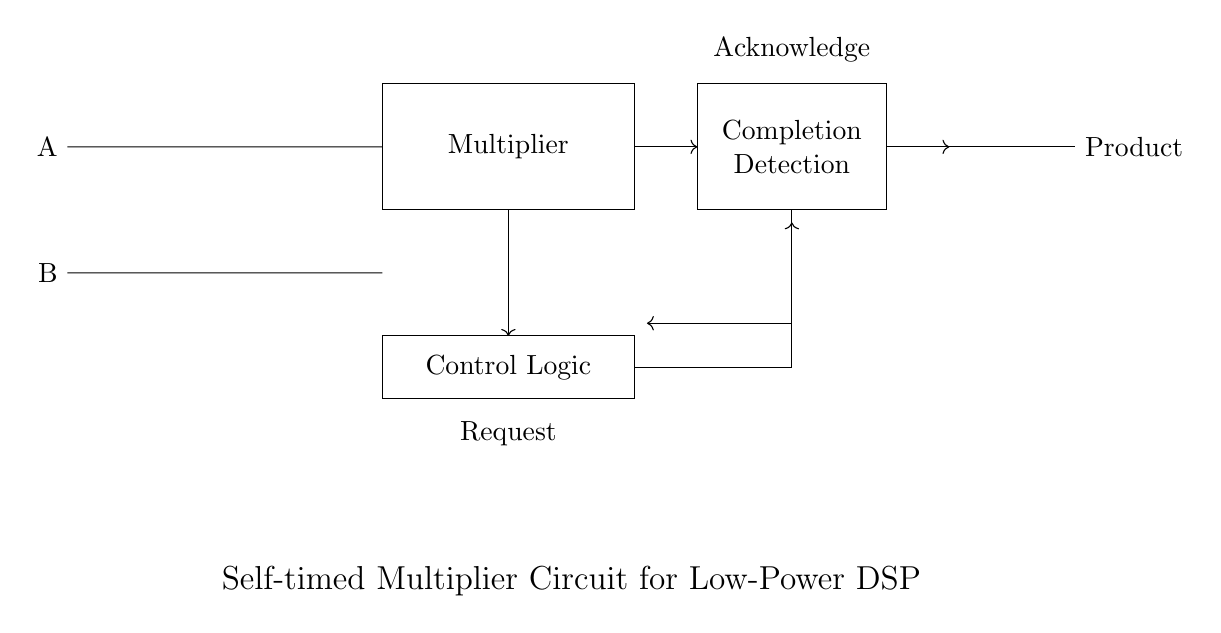What are the two input signals for the multiplier? The two input signals are labeled A and B, which are connected to the input registers on the left side of the circuit diagram.
Answer: A and B What is the purpose of the rectangle labeled "Multiplier"? The "Multiplier" block represents the core functionality of the circuit, where the actual multiplication of inputs A and B takes place.
Answer: Core functionality What type of logic is used for controlling the circuit? The "Control Logic" block located below the multiplier manages the timing and operations of the circuit components, ensuring that the multiplication process is executed correctly and efficiently.
Answer: Control Logic What indicates the completion of the multiplication process? The "Completion Detection" block is used to signal when the multiplication operation has finished, indicating readiness to move on to the next step or to provide the output.
Answer: Completion Detection What is the output of the multiplier labeled as? The output register has the label "Product," which signifies that it stores the result of the multiplication operation of inputs A and B.
Answer: Product How are the control logic signals indicated in the diagram? The diagram shows arrows connecting the control logic to both the multiplier and other components, indicating the flow of control signals throughout the circuit.
Answer: Arrows What is the direction of the signal flows from the multiplier to the output? The signal flows from the multiplier to the 'Completion Detection' and then to the output labeled "Product," as indicated by the direction of the arrows.
Answer: From multiplier to output 